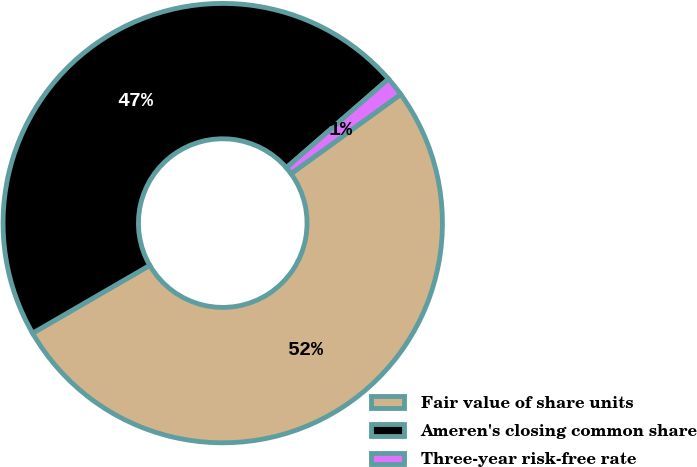Convert chart. <chart><loc_0><loc_0><loc_500><loc_500><pie_chart><fcel>Fair value of share units<fcel>Ameren's closing common share<fcel>Three-year risk-free rate<nl><fcel>51.61%<fcel>46.96%<fcel>1.42%<nl></chart> 